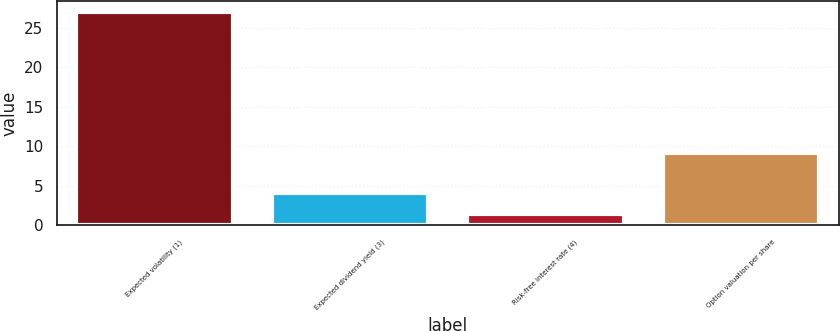<chart> <loc_0><loc_0><loc_500><loc_500><bar_chart><fcel>Expected volatility (1)<fcel>Expected dividend yield (3)<fcel>Risk-free interest rate (4)<fcel>Option valuation per share<nl><fcel>27<fcel>4.05<fcel>1.5<fcel>9.12<nl></chart> 